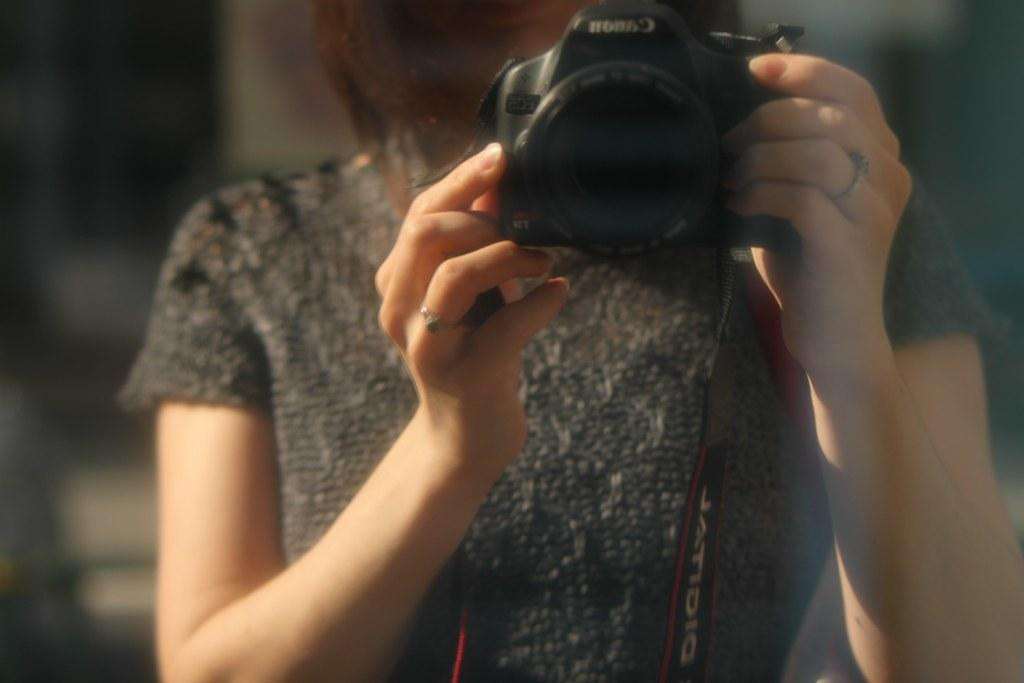Who is taking the picture in the image? There is a person holding the camera in the image. What can be observed about the background of the image? The background of the image is blurred. What type of toothbrush is the person using in the image? There is no toothbrush present in the image, as it features a person holding a camera. What action is the police officer taking in the image? There is no police officer present in the image, so it is not possible to answer that question. 